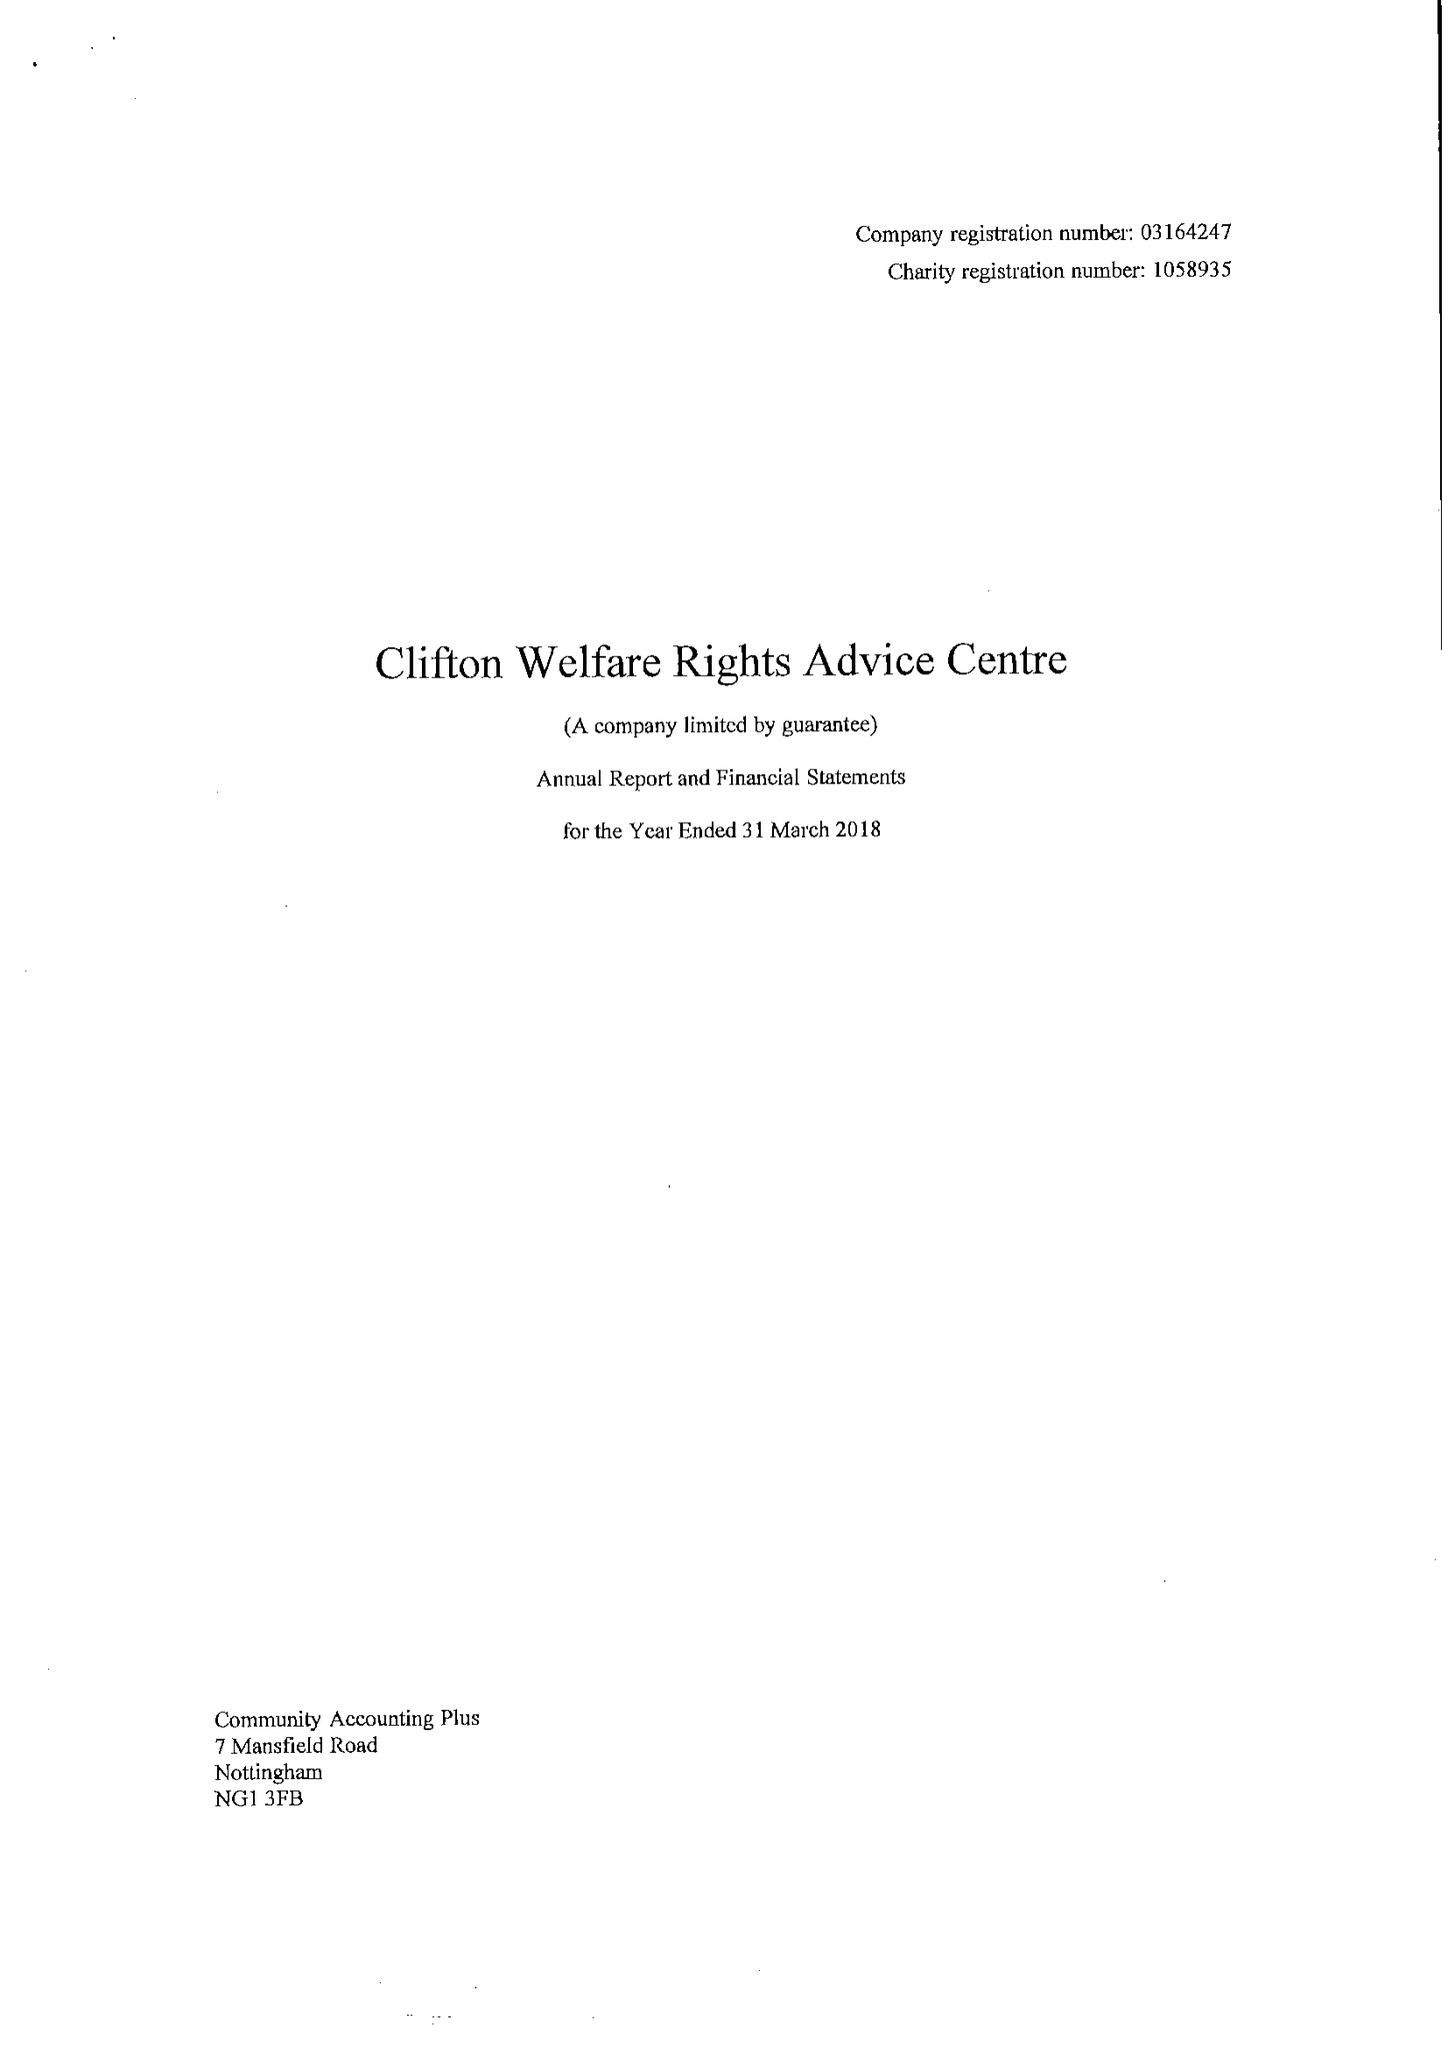What is the value for the address__street_line?
Answer the question using a single word or phrase. SOUTHCHURCH DRIVE 